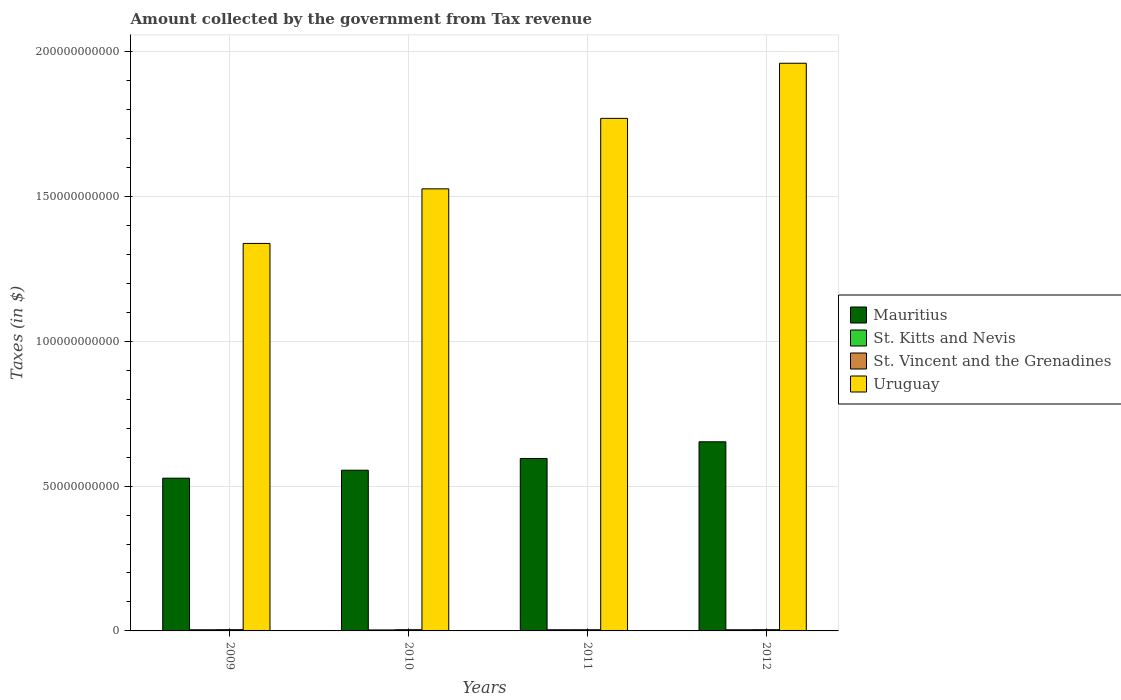How many groups of bars are there?
Ensure brevity in your answer.  4. Are the number of bars on each tick of the X-axis equal?
Make the answer very short. Yes. How many bars are there on the 3rd tick from the left?
Provide a succinct answer. 4. What is the amount collected by the government from tax revenue in Uruguay in 2012?
Give a very brief answer. 1.96e+11. Across all years, what is the maximum amount collected by the government from tax revenue in Uruguay?
Give a very brief answer. 1.96e+11. Across all years, what is the minimum amount collected by the government from tax revenue in Uruguay?
Your answer should be very brief. 1.34e+11. What is the total amount collected by the government from tax revenue in St. Vincent and the Grenadines in the graph?
Your answer should be very brief. 1.70e+09. What is the difference between the amount collected by the government from tax revenue in Uruguay in 2009 and that in 2011?
Offer a very short reply. -4.32e+1. What is the difference between the amount collected by the government from tax revenue in Uruguay in 2010 and the amount collected by the government from tax revenue in St. Vincent and the Grenadines in 2009?
Offer a very short reply. 1.52e+11. What is the average amount collected by the government from tax revenue in St. Vincent and the Grenadines per year?
Your answer should be compact. 4.24e+08. In the year 2011, what is the difference between the amount collected by the government from tax revenue in St. Kitts and Nevis and amount collected by the government from tax revenue in Mauritius?
Offer a very short reply. -5.91e+1. In how many years, is the amount collected by the government from tax revenue in Mauritius greater than 80000000000 $?
Ensure brevity in your answer.  0. What is the ratio of the amount collected by the government from tax revenue in St. Vincent and the Grenadines in 2009 to that in 2011?
Offer a terse response. 1.05. Is the difference between the amount collected by the government from tax revenue in St. Kitts and Nevis in 2010 and 2011 greater than the difference between the amount collected by the government from tax revenue in Mauritius in 2010 and 2011?
Provide a succinct answer. Yes. What is the difference between the highest and the second highest amount collected by the government from tax revenue in St. Vincent and the Grenadines?
Offer a terse response. 2.00e+06. What is the difference between the highest and the lowest amount collected by the government from tax revenue in Mauritius?
Offer a terse response. 1.26e+1. Is the sum of the amount collected by the government from tax revenue in Mauritius in 2009 and 2010 greater than the maximum amount collected by the government from tax revenue in St. Kitts and Nevis across all years?
Your answer should be compact. Yes. Is it the case that in every year, the sum of the amount collected by the government from tax revenue in St. Vincent and the Grenadines and amount collected by the government from tax revenue in Mauritius is greater than the sum of amount collected by the government from tax revenue in Uruguay and amount collected by the government from tax revenue in St. Kitts and Nevis?
Offer a terse response. No. What does the 1st bar from the left in 2010 represents?
Keep it short and to the point. Mauritius. What does the 1st bar from the right in 2011 represents?
Provide a short and direct response. Uruguay. Is it the case that in every year, the sum of the amount collected by the government from tax revenue in St. Vincent and the Grenadines and amount collected by the government from tax revenue in Mauritius is greater than the amount collected by the government from tax revenue in St. Kitts and Nevis?
Give a very brief answer. Yes. How many bars are there?
Offer a terse response. 16. Are all the bars in the graph horizontal?
Give a very brief answer. No. How many years are there in the graph?
Your response must be concise. 4. Does the graph contain any zero values?
Your response must be concise. No. Does the graph contain grids?
Your response must be concise. Yes. Where does the legend appear in the graph?
Make the answer very short. Center right. How many legend labels are there?
Your response must be concise. 4. What is the title of the graph?
Give a very brief answer. Amount collected by the government from Tax revenue. What is the label or title of the Y-axis?
Offer a very short reply. Taxes (in $). What is the Taxes (in $) of Mauritius in 2009?
Offer a terse response. 5.27e+1. What is the Taxes (in $) of St. Kitts and Nevis in 2009?
Give a very brief answer. 3.94e+08. What is the Taxes (in $) of St. Vincent and the Grenadines in 2009?
Make the answer very short. 4.33e+08. What is the Taxes (in $) in Uruguay in 2009?
Give a very brief answer. 1.34e+11. What is the Taxes (in $) of Mauritius in 2010?
Ensure brevity in your answer.  5.55e+1. What is the Taxes (in $) in St. Kitts and Nevis in 2010?
Make the answer very short. 3.43e+08. What is the Taxes (in $) of St. Vincent and the Grenadines in 2010?
Provide a short and direct response. 4.22e+08. What is the Taxes (in $) of Uruguay in 2010?
Your answer should be very brief. 1.53e+11. What is the Taxes (in $) of Mauritius in 2011?
Offer a very short reply. 5.95e+1. What is the Taxes (in $) of St. Kitts and Nevis in 2011?
Ensure brevity in your answer.  4.08e+08. What is the Taxes (in $) of St. Vincent and the Grenadines in 2011?
Give a very brief answer. 4.12e+08. What is the Taxes (in $) in Uruguay in 2011?
Provide a succinct answer. 1.77e+11. What is the Taxes (in $) of Mauritius in 2012?
Offer a terse response. 6.53e+1. What is the Taxes (in $) of St. Kitts and Nevis in 2012?
Give a very brief answer. 3.99e+08. What is the Taxes (in $) in St. Vincent and the Grenadines in 2012?
Your response must be concise. 4.31e+08. What is the Taxes (in $) in Uruguay in 2012?
Give a very brief answer. 1.96e+11. Across all years, what is the maximum Taxes (in $) of Mauritius?
Offer a very short reply. 6.53e+1. Across all years, what is the maximum Taxes (in $) of St. Kitts and Nevis?
Provide a succinct answer. 4.08e+08. Across all years, what is the maximum Taxes (in $) in St. Vincent and the Grenadines?
Make the answer very short. 4.33e+08. Across all years, what is the maximum Taxes (in $) in Uruguay?
Offer a very short reply. 1.96e+11. Across all years, what is the minimum Taxes (in $) of Mauritius?
Your answer should be compact. 5.27e+1. Across all years, what is the minimum Taxes (in $) in St. Kitts and Nevis?
Provide a short and direct response. 3.43e+08. Across all years, what is the minimum Taxes (in $) in St. Vincent and the Grenadines?
Your answer should be compact. 4.12e+08. Across all years, what is the minimum Taxes (in $) of Uruguay?
Offer a terse response. 1.34e+11. What is the total Taxes (in $) of Mauritius in the graph?
Give a very brief answer. 2.33e+11. What is the total Taxes (in $) in St. Kitts and Nevis in the graph?
Ensure brevity in your answer.  1.54e+09. What is the total Taxes (in $) in St. Vincent and the Grenadines in the graph?
Offer a terse response. 1.70e+09. What is the total Taxes (in $) in Uruguay in the graph?
Provide a short and direct response. 6.59e+11. What is the difference between the Taxes (in $) of Mauritius in 2009 and that in 2010?
Offer a terse response. -2.75e+09. What is the difference between the Taxes (in $) of St. Kitts and Nevis in 2009 and that in 2010?
Your answer should be very brief. 5.15e+07. What is the difference between the Taxes (in $) of St. Vincent and the Grenadines in 2009 and that in 2010?
Offer a very short reply. 1.11e+07. What is the difference between the Taxes (in $) in Uruguay in 2009 and that in 2010?
Offer a very short reply. -1.88e+1. What is the difference between the Taxes (in $) in Mauritius in 2009 and that in 2011?
Provide a succinct answer. -6.80e+09. What is the difference between the Taxes (in $) of St. Kitts and Nevis in 2009 and that in 2011?
Give a very brief answer. -1.35e+07. What is the difference between the Taxes (in $) in St. Vincent and the Grenadines in 2009 and that in 2011?
Offer a very short reply. 2.05e+07. What is the difference between the Taxes (in $) in Uruguay in 2009 and that in 2011?
Your response must be concise. -4.32e+1. What is the difference between the Taxes (in $) of Mauritius in 2009 and that in 2012?
Provide a succinct answer. -1.26e+1. What is the difference between the Taxes (in $) in St. Kitts and Nevis in 2009 and that in 2012?
Offer a very short reply. -4.50e+06. What is the difference between the Taxes (in $) of Uruguay in 2009 and that in 2012?
Provide a short and direct response. -6.22e+1. What is the difference between the Taxes (in $) of Mauritius in 2010 and that in 2011?
Your answer should be very brief. -4.05e+09. What is the difference between the Taxes (in $) in St. Kitts and Nevis in 2010 and that in 2011?
Offer a very short reply. -6.50e+07. What is the difference between the Taxes (in $) of St. Vincent and the Grenadines in 2010 and that in 2011?
Provide a short and direct response. 9.40e+06. What is the difference between the Taxes (in $) of Uruguay in 2010 and that in 2011?
Your answer should be compact. -2.43e+1. What is the difference between the Taxes (in $) of Mauritius in 2010 and that in 2012?
Your response must be concise. -9.81e+09. What is the difference between the Taxes (in $) of St. Kitts and Nevis in 2010 and that in 2012?
Your response must be concise. -5.60e+07. What is the difference between the Taxes (in $) in St. Vincent and the Grenadines in 2010 and that in 2012?
Provide a succinct answer. -9.10e+06. What is the difference between the Taxes (in $) in Uruguay in 2010 and that in 2012?
Provide a succinct answer. -4.34e+1. What is the difference between the Taxes (in $) in Mauritius in 2011 and that in 2012?
Provide a short and direct response. -5.76e+09. What is the difference between the Taxes (in $) in St. Kitts and Nevis in 2011 and that in 2012?
Your answer should be very brief. 9.00e+06. What is the difference between the Taxes (in $) in St. Vincent and the Grenadines in 2011 and that in 2012?
Provide a succinct answer. -1.85e+07. What is the difference between the Taxes (in $) of Uruguay in 2011 and that in 2012?
Offer a terse response. -1.90e+1. What is the difference between the Taxes (in $) of Mauritius in 2009 and the Taxes (in $) of St. Kitts and Nevis in 2010?
Provide a succinct answer. 5.24e+1. What is the difference between the Taxes (in $) in Mauritius in 2009 and the Taxes (in $) in St. Vincent and the Grenadines in 2010?
Keep it short and to the point. 5.23e+1. What is the difference between the Taxes (in $) in Mauritius in 2009 and the Taxes (in $) in Uruguay in 2010?
Your answer should be compact. -9.99e+1. What is the difference between the Taxes (in $) of St. Kitts and Nevis in 2009 and the Taxes (in $) of St. Vincent and the Grenadines in 2010?
Make the answer very short. -2.70e+07. What is the difference between the Taxes (in $) in St. Kitts and Nevis in 2009 and the Taxes (in $) in Uruguay in 2010?
Ensure brevity in your answer.  -1.52e+11. What is the difference between the Taxes (in $) of St. Vincent and the Grenadines in 2009 and the Taxes (in $) of Uruguay in 2010?
Your answer should be compact. -1.52e+11. What is the difference between the Taxes (in $) in Mauritius in 2009 and the Taxes (in $) in St. Kitts and Nevis in 2011?
Ensure brevity in your answer.  5.23e+1. What is the difference between the Taxes (in $) in Mauritius in 2009 and the Taxes (in $) in St. Vincent and the Grenadines in 2011?
Provide a succinct answer. 5.23e+1. What is the difference between the Taxes (in $) in Mauritius in 2009 and the Taxes (in $) in Uruguay in 2011?
Offer a terse response. -1.24e+11. What is the difference between the Taxes (in $) of St. Kitts and Nevis in 2009 and the Taxes (in $) of St. Vincent and the Grenadines in 2011?
Ensure brevity in your answer.  -1.76e+07. What is the difference between the Taxes (in $) in St. Kitts and Nevis in 2009 and the Taxes (in $) in Uruguay in 2011?
Ensure brevity in your answer.  -1.77e+11. What is the difference between the Taxes (in $) of St. Vincent and the Grenadines in 2009 and the Taxes (in $) of Uruguay in 2011?
Ensure brevity in your answer.  -1.77e+11. What is the difference between the Taxes (in $) of Mauritius in 2009 and the Taxes (in $) of St. Kitts and Nevis in 2012?
Offer a very short reply. 5.23e+1. What is the difference between the Taxes (in $) of Mauritius in 2009 and the Taxes (in $) of St. Vincent and the Grenadines in 2012?
Offer a very short reply. 5.23e+1. What is the difference between the Taxes (in $) of Mauritius in 2009 and the Taxes (in $) of Uruguay in 2012?
Offer a terse response. -1.43e+11. What is the difference between the Taxes (in $) in St. Kitts and Nevis in 2009 and the Taxes (in $) in St. Vincent and the Grenadines in 2012?
Offer a terse response. -3.61e+07. What is the difference between the Taxes (in $) of St. Kitts and Nevis in 2009 and the Taxes (in $) of Uruguay in 2012?
Provide a succinct answer. -1.96e+11. What is the difference between the Taxes (in $) of St. Vincent and the Grenadines in 2009 and the Taxes (in $) of Uruguay in 2012?
Provide a succinct answer. -1.96e+11. What is the difference between the Taxes (in $) in Mauritius in 2010 and the Taxes (in $) in St. Kitts and Nevis in 2011?
Make the answer very short. 5.51e+1. What is the difference between the Taxes (in $) in Mauritius in 2010 and the Taxes (in $) in St. Vincent and the Grenadines in 2011?
Make the answer very short. 5.51e+1. What is the difference between the Taxes (in $) in Mauritius in 2010 and the Taxes (in $) in Uruguay in 2011?
Your answer should be compact. -1.21e+11. What is the difference between the Taxes (in $) in St. Kitts and Nevis in 2010 and the Taxes (in $) in St. Vincent and the Grenadines in 2011?
Ensure brevity in your answer.  -6.91e+07. What is the difference between the Taxes (in $) in St. Kitts and Nevis in 2010 and the Taxes (in $) in Uruguay in 2011?
Your answer should be very brief. -1.77e+11. What is the difference between the Taxes (in $) in St. Vincent and the Grenadines in 2010 and the Taxes (in $) in Uruguay in 2011?
Keep it short and to the point. -1.77e+11. What is the difference between the Taxes (in $) in Mauritius in 2010 and the Taxes (in $) in St. Kitts and Nevis in 2012?
Your response must be concise. 5.51e+1. What is the difference between the Taxes (in $) of Mauritius in 2010 and the Taxes (in $) of St. Vincent and the Grenadines in 2012?
Keep it short and to the point. 5.51e+1. What is the difference between the Taxes (in $) in Mauritius in 2010 and the Taxes (in $) in Uruguay in 2012?
Ensure brevity in your answer.  -1.40e+11. What is the difference between the Taxes (in $) of St. Kitts and Nevis in 2010 and the Taxes (in $) of St. Vincent and the Grenadines in 2012?
Keep it short and to the point. -8.76e+07. What is the difference between the Taxes (in $) of St. Kitts and Nevis in 2010 and the Taxes (in $) of Uruguay in 2012?
Provide a succinct answer. -1.96e+11. What is the difference between the Taxes (in $) in St. Vincent and the Grenadines in 2010 and the Taxes (in $) in Uruguay in 2012?
Keep it short and to the point. -1.96e+11. What is the difference between the Taxes (in $) of Mauritius in 2011 and the Taxes (in $) of St. Kitts and Nevis in 2012?
Make the answer very short. 5.91e+1. What is the difference between the Taxes (in $) of Mauritius in 2011 and the Taxes (in $) of St. Vincent and the Grenadines in 2012?
Your response must be concise. 5.91e+1. What is the difference between the Taxes (in $) of Mauritius in 2011 and the Taxes (in $) of Uruguay in 2012?
Your answer should be compact. -1.36e+11. What is the difference between the Taxes (in $) of St. Kitts and Nevis in 2011 and the Taxes (in $) of St. Vincent and the Grenadines in 2012?
Keep it short and to the point. -2.26e+07. What is the difference between the Taxes (in $) in St. Kitts and Nevis in 2011 and the Taxes (in $) in Uruguay in 2012?
Make the answer very short. -1.96e+11. What is the difference between the Taxes (in $) of St. Vincent and the Grenadines in 2011 and the Taxes (in $) of Uruguay in 2012?
Provide a succinct answer. -1.96e+11. What is the average Taxes (in $) in Mauritius per year?
Give a very brief answer. 5.83e+1. What is the average Taxes (in $) of St. Kitts and Nevis per year?
Keep it short and to the point. 3.86e+08. What is the average Taxes (in $) in St. Vincent and the Grenadines per year?
Offer a terse response. 4.24e+08. What is the average Taxes (in $) of Uruguay per year?
Ensure brevity in your answer.  1.65e+11. In the year 2009, what is the difference between the Taxes (in $) of Mauritius and Taxes (in $) of St. Kitts and Nevis?
Offer a terse response. 5.23e+1. In the year 2009, what is the difference between the Taxes (in $) in Mauritius and Taxes (in $) in St. Vincent and the Grenadines?
Provide a succinct answer. 5.23e+1. In the year 2009, what is the difference between the Taxes (in $) in Mauritius and Taxes (in $) in Uruguay?
Keep it short and to the point. -8.10e+1. In the year 2009, what is the difference between the Taxes (in $) in St. Kitts and Nevis and Taxes (in $) in St. Vincent and the Grenadines?
Provide a short and direct response. -3.81e+07. In the year 2009, what is the difference between the Taxes (in $) of St. Kitts and Nevis and Taxes (in $) of Uruguay?
Keep it short and to the point. -1.33e+11. In the year 2009, what is the difference between the Taxes (in $) of St. Vincent and the Grenadines and Taxes (in $) of Uruguay?
Keep it short and to the point. -1.33e+11. In the year 2010, what is the difference between the Taxes (in $) in Mauritius and Taxes (in $) in St. Kitts and Nevis?
Ensure brevity in your answer.  5.51e+1. In the year 2010, what is the difference between the Taxes (in $) in Mauritius and Taxes (in $) in St. Vincent and the Grenadines?
Ensure brevity in your answer.  5.51e+1. In the year 2010, what is the difference between the Taxes (in $) in Mauritius and Taxes (in $) in Uruguay?
Your response must be concise. -9.71e+1. In the year 2010, what is the difference between the Taxes (in $) of St. Kitts and Nevis and Taxes (in $) of St. Vincent and the Grenadines?
Your response must be concise. -7.85e+07. In the year 2010, what is the difference between the Taxes (in $) of St. Kitts and Nevis and Taxes (in $) of Uruguay?
Give a very brief answer. -1.52e+11. In the year 2010, what is the difference between the Taxes (in $) of St. Vincent and the Grenadines and Taxes (in $) of Uruguay?
Your answer should be very brief. -1.52e+11. In the year 2011, what is the difference between the Taxes (in $) in Mauritius and Taxes (in $) in St. Kitts and Nevis?
Offer a very short reply. 5.91e+1. In the year 2011, what is the difference between the Taxes (in $) in Mauritius and Taxes (in $) in St. Vincent and the Grenadines?
Your answer should be compact. 5.91e+1. In the year 2011, what is the difference between the Taxes (in $) in Mauritius and Taxes (in $) in Uruguay?
Ensure brevity in your answer.  -1.17e+11. In the year 2011, what is the difference between the Taxes (in $) in St. Kitts and Nevis and Taxes (in $) in St. Vincent and the Grenadines?
Make the answer very short. -4.10e+06. In the year 2011, what is the difference between the Taxes (in $) in St. Kitts and Nevis and Taxes (in $) in Uruguay?
Give a very brief answer. -1.77e+11. In the year 2011, what is the difference between the Taxes (in $) in St. Vincent and the Grenadines and Taxes (in $) in Uruguay?
Offer a very short reply. -1.77e+11. In the year 2012, what is the difference between the Taxes (in $) of Mauritius and Taxes (in $) of St. Kitts and Nevis?
Your answer should be very brief. 6.49e+1. In the year 2012, what is the difference between the Taxes (in $) in Mauritius and Taxes (in $) in St. Vincent and the Grenadines?
Make the answer very short. 6.49e+1. In the year 2012, what is the difference between the Taxes (in $) of Mauritius and Taxes (in $) of Uruguay?
Give a very brief answer. -1.31e+11. In the year 2012, what is the difference between the Taxes (in $) of St. Kitts and Nevis and Taxes (in $) of St. Vincent and the Grenadines?
Provide a short and direct response. -3.16e+07. In the year 2012, what is the difference between the Taxes (in $) of St. Kitts and Nevis and Taxes (in $) of Uruguay?
Your response must be concise. -1.96e+11. In the year 2012, what is the difference between the Taxes (in $) of St. Vincent and the Grenadines and Taxes (in $) of Uruguay?
Your answer should be compact. -1.96e+11. What is the ratio of the Taxes (in $) in Mauritius in 2009 to that in 2010?
Keep it short and to the point. 0.95. What is the ratio of the Taxes (in $) in St. Kitts and Nevis in 2009 to that in 2010?
Make the answer very short. 1.15. What is the ratio of the Taxes (in $) of St. Vincent and the Grenadines in 2009 to that in 2010?
Give a very brief answer. 1.03. What is the ratio of the Taxes (in $) in Uruguay in 2009 to that in 2010?
Provide a short and direct response. 0.88. What is the ratio of the Taxes (in $) of Mauritius in 2009 to that in 2011?
Your answer should be compact. 0.89. What is the ratio of the Taxes (in $) in St. Kitts and Nevis in 2009 to that in 2011?
Give a very brief answer. 0.97. What is the ratio of the Taxes (in $) in St. Vincent and the Grenadines in 2009 to that in 2011?
Your response must be concise. 1.05. What is the ratio of the Taxes (in $) of Uruguay in 2009 to that in 2011?
Your response must be concise. 0.76. What is the ratio of the Taxes (in $) of Mauritius in 2009 to that in 2012?
Give a very brief answer. 0.81. What is the ratio of the Taxes (in $) of St. Kitts and Nevis in 2009 to that in 2012?
Your answer should be compact. 0.99. What is the ratio of the Taxes (in $) in St. Vincent and the Grenadines in 2009 to that in 2012?
Ensure brevity in your answer.  1. What is the ratio of the Taxes (in $) of Uruguay in 2009 to that in 2012?
Your answer should be very brief. 0.68. What is the ratio of the Taxes (in $) of Mauritius in 2010 to that in 2011?
Make the answer very short. 0.93. What is the ratio of the Taxes (in $) in St. Kitts and Nevis in 2010 to that in 2011?
Offer a very short reply. 0.84. What is the ratio of the Taxes (in $) in St. Vincent and the Grenadines in 2010 to that in 2011?
Provide a succinct answer. 1.02. What is the ratio of the Taxes (in $) in Uruguay in 2010 to that in 2011?
Give a very brief answer. 0.86. What is the ratio of the Taxes (in $) in Mauritius in 2010 to that in 2012?
Offer a terse response. 0.85. What is the ratio of the Taxes (in $) of St. Kitts and Nevis in 2010 to that in 2012?
Your response must be concise. 0.86. What is the ratio of the Taxes (in $) of St. Vincent and the Grenadines in 2010 to that in 2012?
Keep it short and to the point. 0.98. What is the ratio of the Taxes (in $) in Uruguay in 2010 to that in 2012?
Provide a succinct answer. 0.78. What is the ratio of the Taxes (in $) in Mauritius in 2011 to that in 2012?
Your answer should be compact. 0.91. What is the ratio of the Taxes (in $) of St. Kitts and Nevis in 2011 to that in 2012?
Ensure brevity in your answer.  1.02. What is the ratio of the Taxes (in $) of St. Vincent and the Grenadines in 2011 to that in 2012?
Provide a succinct answer. 0.96. What is the ratio of the Taxes (in $) of Uruguay in 2011 to that in 2012?
Give a very brief answer. 0.9. What is the difference between the highest and the second highest Taxes (in $) in Mauritius?
Give a very brief answer. 5.76e+09. What is the difference between the highest and the second highest Taxes (in $) of St. Kitts and Nevis?
Your answer should be compact. 9.00e+06. What is the difference between the highest and the second highest Taxes (in $) in Uruguay?
Your answer should be very brief. 1.90e+1. What is the difference between the highest and the lowest Taxes (in $) of Mauritius?
Offer a very short reply. 1.26e+1. What is the difference between the highest and the lowest Taxes (in $) in St. Kitts and Nevis?
Make the answer very short. 6.50e+07. What is the difference between the highest and the lowest Taxes (in $) of St. Vincent and the Grenadines?
Keep it short and to the point. 2.05e+07. What is the difference between the highest and the lowest Taxes (in $) in Uruguay?
Your response must be concise. 6.22e+1. 